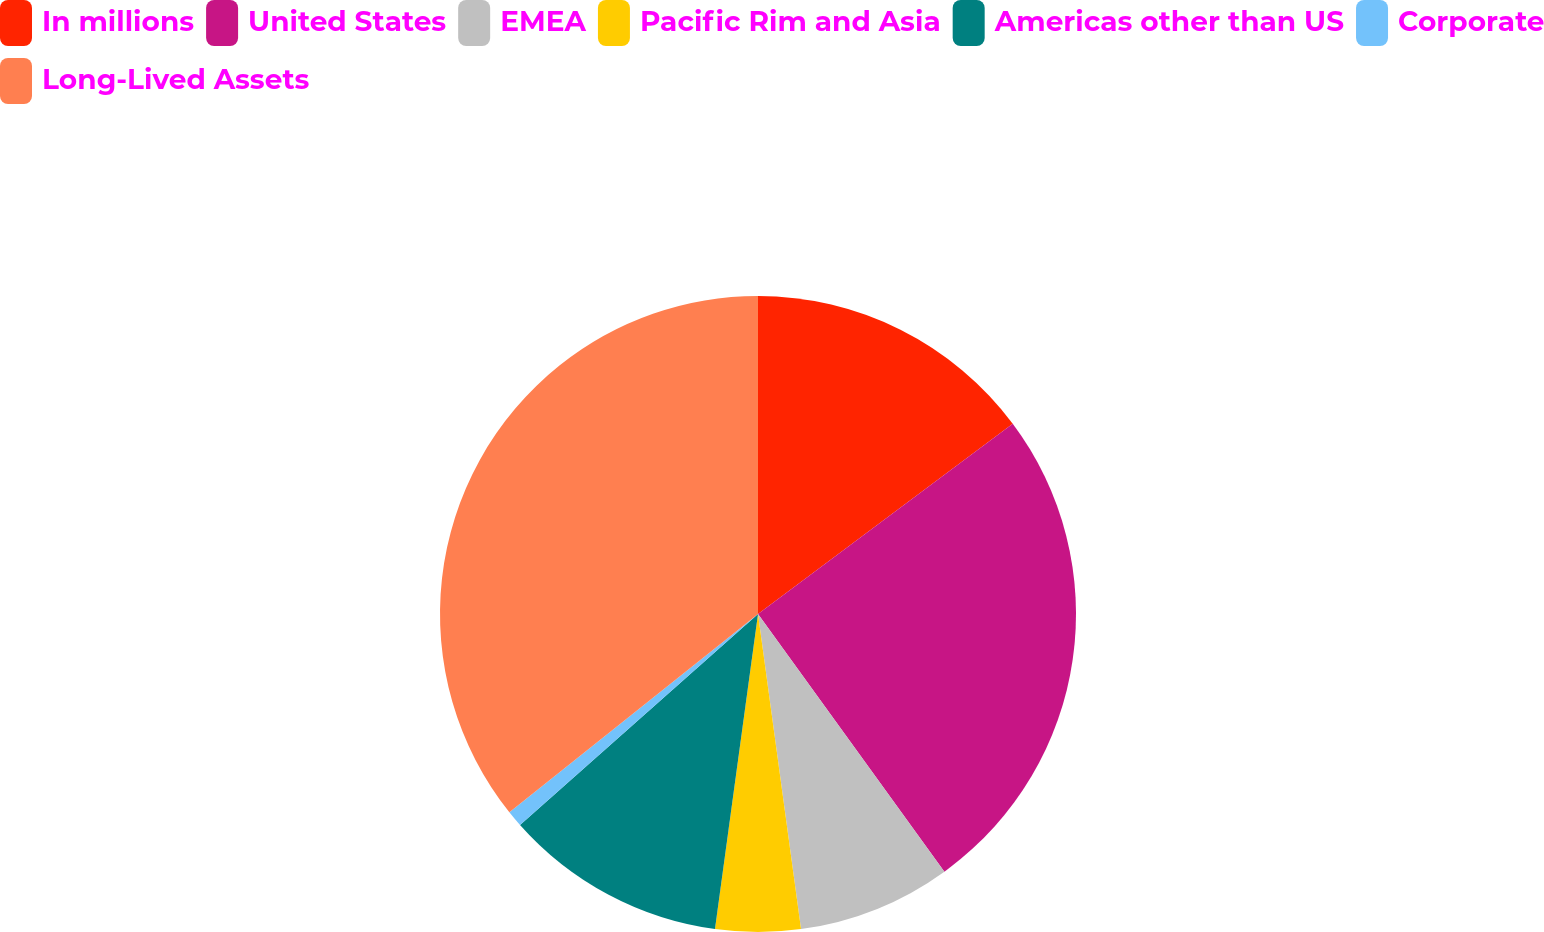Convert chart. <chart><loc_0><loc_0><loc_500><loc_500><pie_chart><fcel>In millions<fcel>United States<fcel>EMEA<fcel>Pacific Rim and Asia<fcel>Americas other than US<fcel>Corporate<fcel>Long-Lived Assets<nl><fcel>14.79%<fcel>25.25%<fcel>7.81%<fcel>4.32%<fcel>11.3%<fcel>0.83%<fcel>35.72%<nl></chart> 